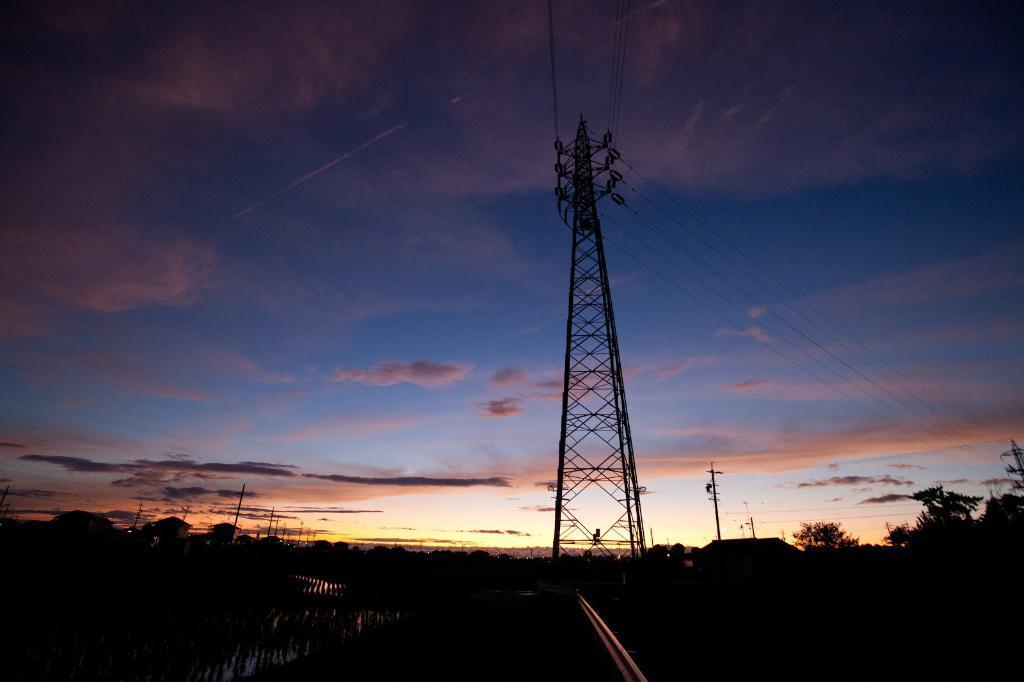Can you describe this image briefly? In this picture we can see a tower in the middle, on the left side there are some houses, in the background there are trees and a poke, we can see the sky and clouds at the top of the picture, we can see some wires on the right side. 